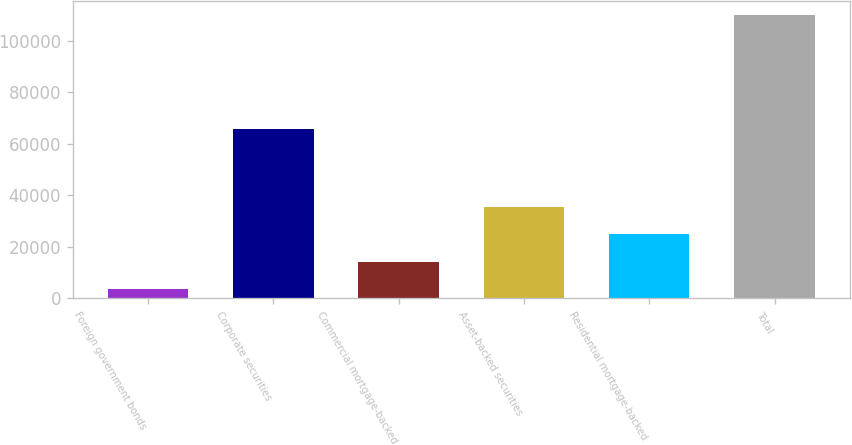Convert chart. <chart><loc_0><loc_0><loc_500><loc_500><bar_chart><fcel>Foreign government bonds<fcel>Corporate securities<fcel>Commercial mortgage-backed<fcel>Asset-backed securities<fcel>Residential mortgage-backed<fcel>Total<nl><fcel>3633<fcel>65577<fcel>14249.5<fcel>35482.5<fcel>24866<fcel>109798<nl></chart> 